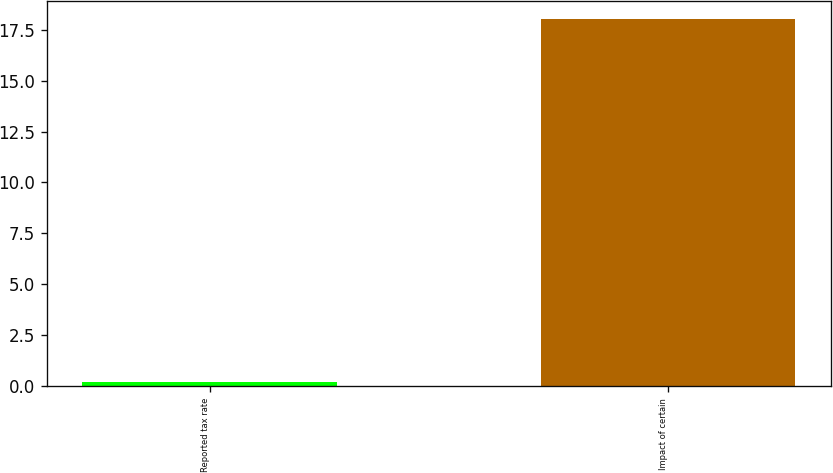Convert chart to OTSL. <chart><loc_0><loc_0><loc_500><loc_500><bar_chart><fcel>Reported tax rate<fcel>Impact of certain<nl><fcel>0.2<fcel>18<nl></chart> 